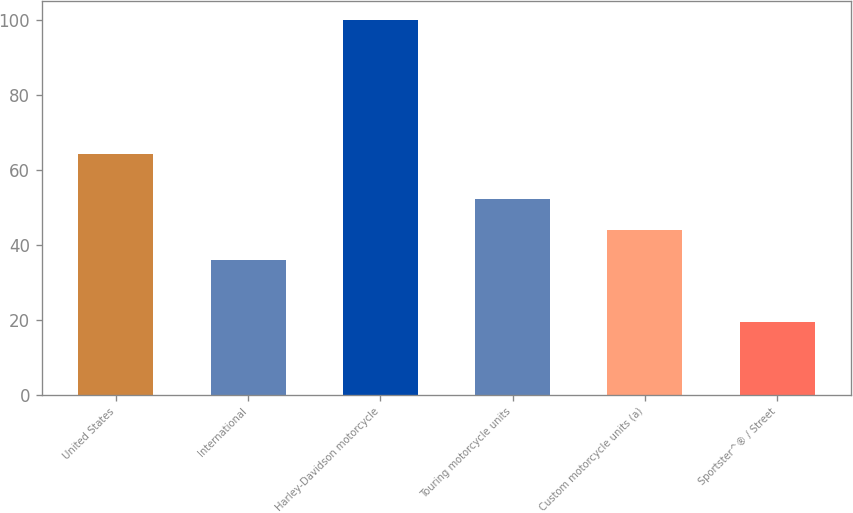Convert chart to OTSL. <chart><loc_0><loc_0><loc_500><loc_500><bar_chart><fcel>United States<fcel>International<fcel>Harley-Davidson motorcycle<fcel>Touring motorcycle units<fcel>Custom motorcycle units (a)<fcel>Sportster^® / Street<nl><fcel>64.1<fcel>35.9<fcel>100<fcel>52.04<fcel>43.97<fcel>19.3<nl></chart> 